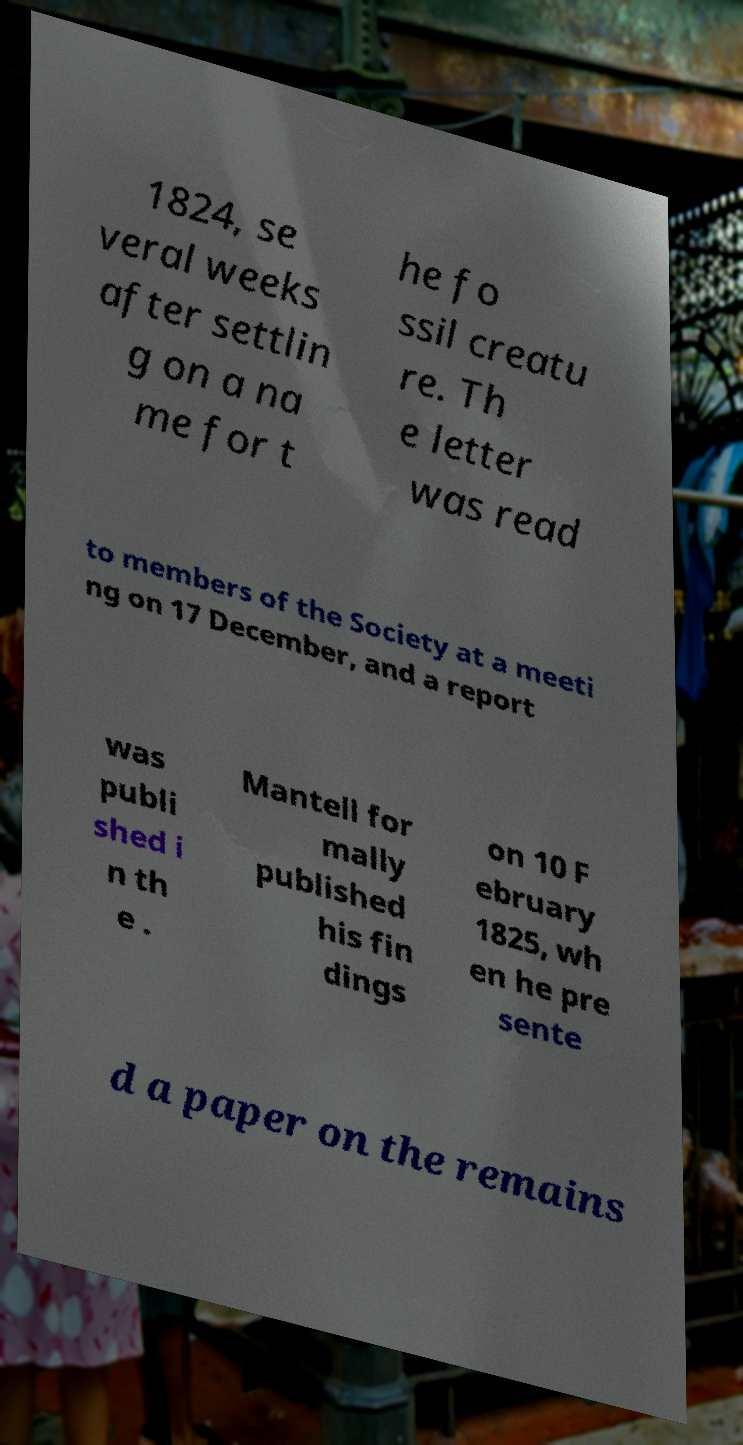Please read and relay the text visible in this image. What does it say? 1824, se veral weeks after settlin g on a na me for t he fo ssil creatu re. Th e letter was read to members of the Society at a meeti ng on 17 December, and a report was publi shed i n th e . Mantell for mally published his fin dings on 10 F ebruary 1825, wh en he pre sente d a paper on the remains 